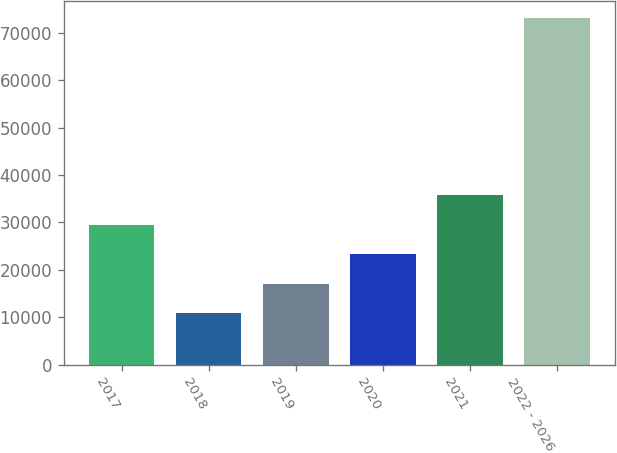Convert chart. <chart><loc_0><loc_0><loc_500><loc_500><bar_chart><fcel>2017<fcel>2018<fcel>2019<fcel>2020<fcel>2021<fcel>2022 - 2026<nl><fcel>29507<fcel>10781<fcel>17023<fcel>23265<fcel>35749<fcel>73201<nl></chart> 